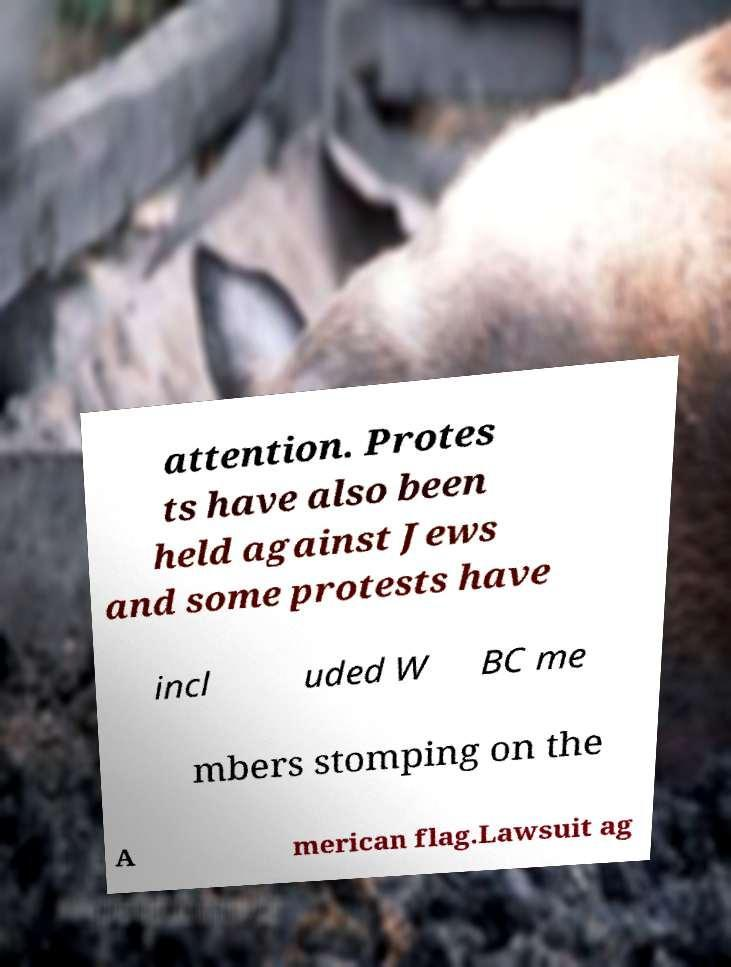Please identify and transcribe the text found in this image. attention. Protes ts have also been held against Jews and some protests have incl uded W BC me mbers stomping on the A merican flag.Lawsuit ag 